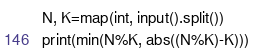Convert code to text. <code><loc_0><loc_0><loc_500><loc_500><_Python_>N, K=map(int, input().split())
print(min(N%K, abs((N%K)-K)))</code> 